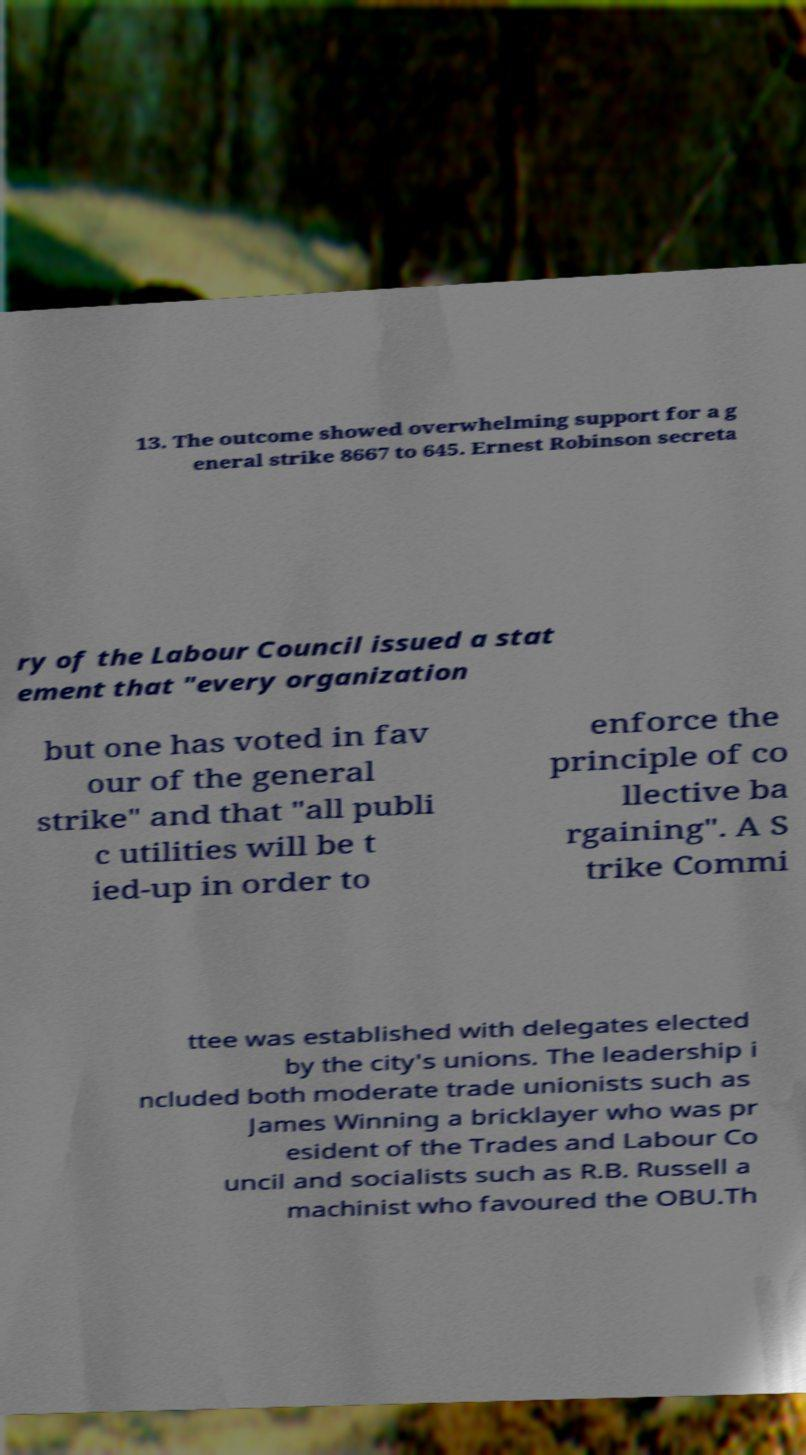I need the written content from this picture converted into text. Can you do that? 13. The outcome showed overwhelming support for a g eneral strike 8667 to 645. Ernest Robinson secreta ry of the Labour Council issued a stat ement that "every organization but one has voted in fav our of the general strike" and that "all publi c utilities will be t ied-up in order to enforce the principle of co llective ba rgaining". A S trike Commi ttee was established with delegates elected by the city's unions. The leadership i ncluded both moderate trade unionists such as James Winning a bricklayer who was pr esident of the Trades and Labour Co uncil and socialists such as R.B. Russell a machinist who favoured the OBU.Th 